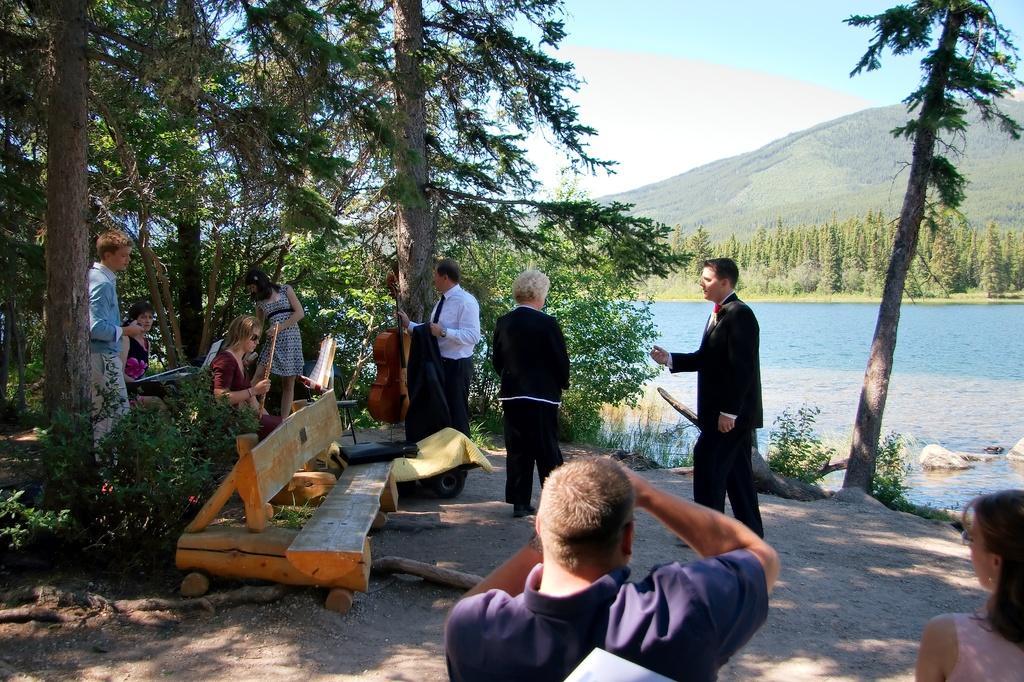How would you summarize this image in a sentence or two? In this picture we can see some people are sitting and some people are standing, we can see water in the background and some trees, we can also see some hills here, in the middle there is a bench. 